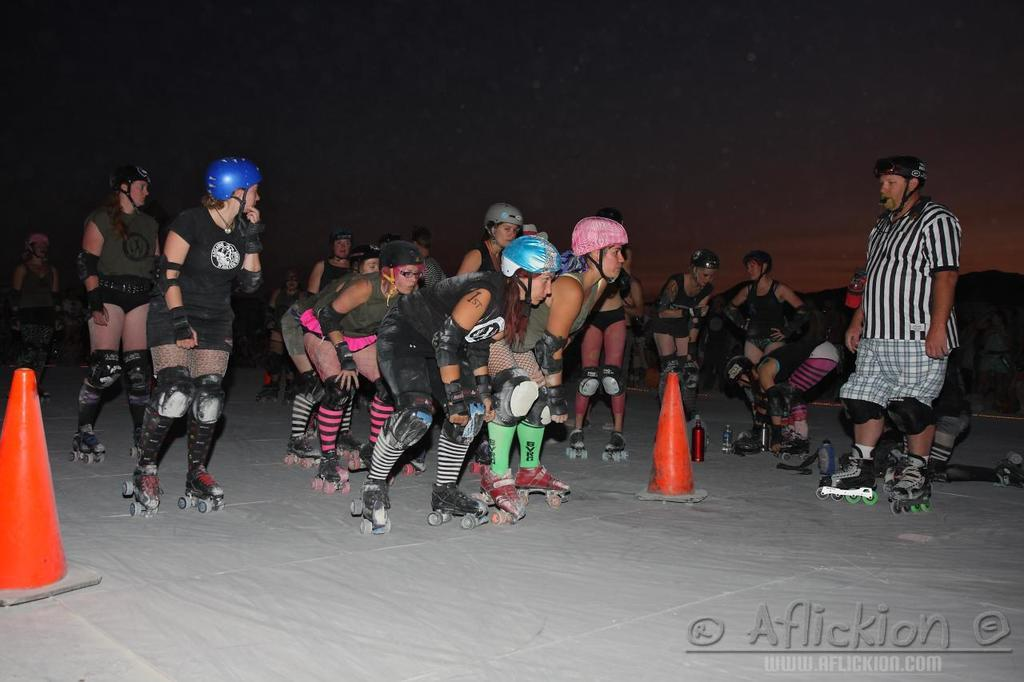What are the people in the image wearing on their feet? The people in the image are wearing skates. What protective gear are the people wearing in the image? The people are also wearing helmets. What can be found on the ground in the image? There are bottles and orange color objects on the ground in the image. What is visible in the background of the image? Mountains and the sky are visible in the background of the image. What type of plant is growing on the ice in the image? There is no plant or ice present in the image. What degree of difficulty is the skating performance in the image? The image does not provide information about the degree of difficulty of the skating performance. 